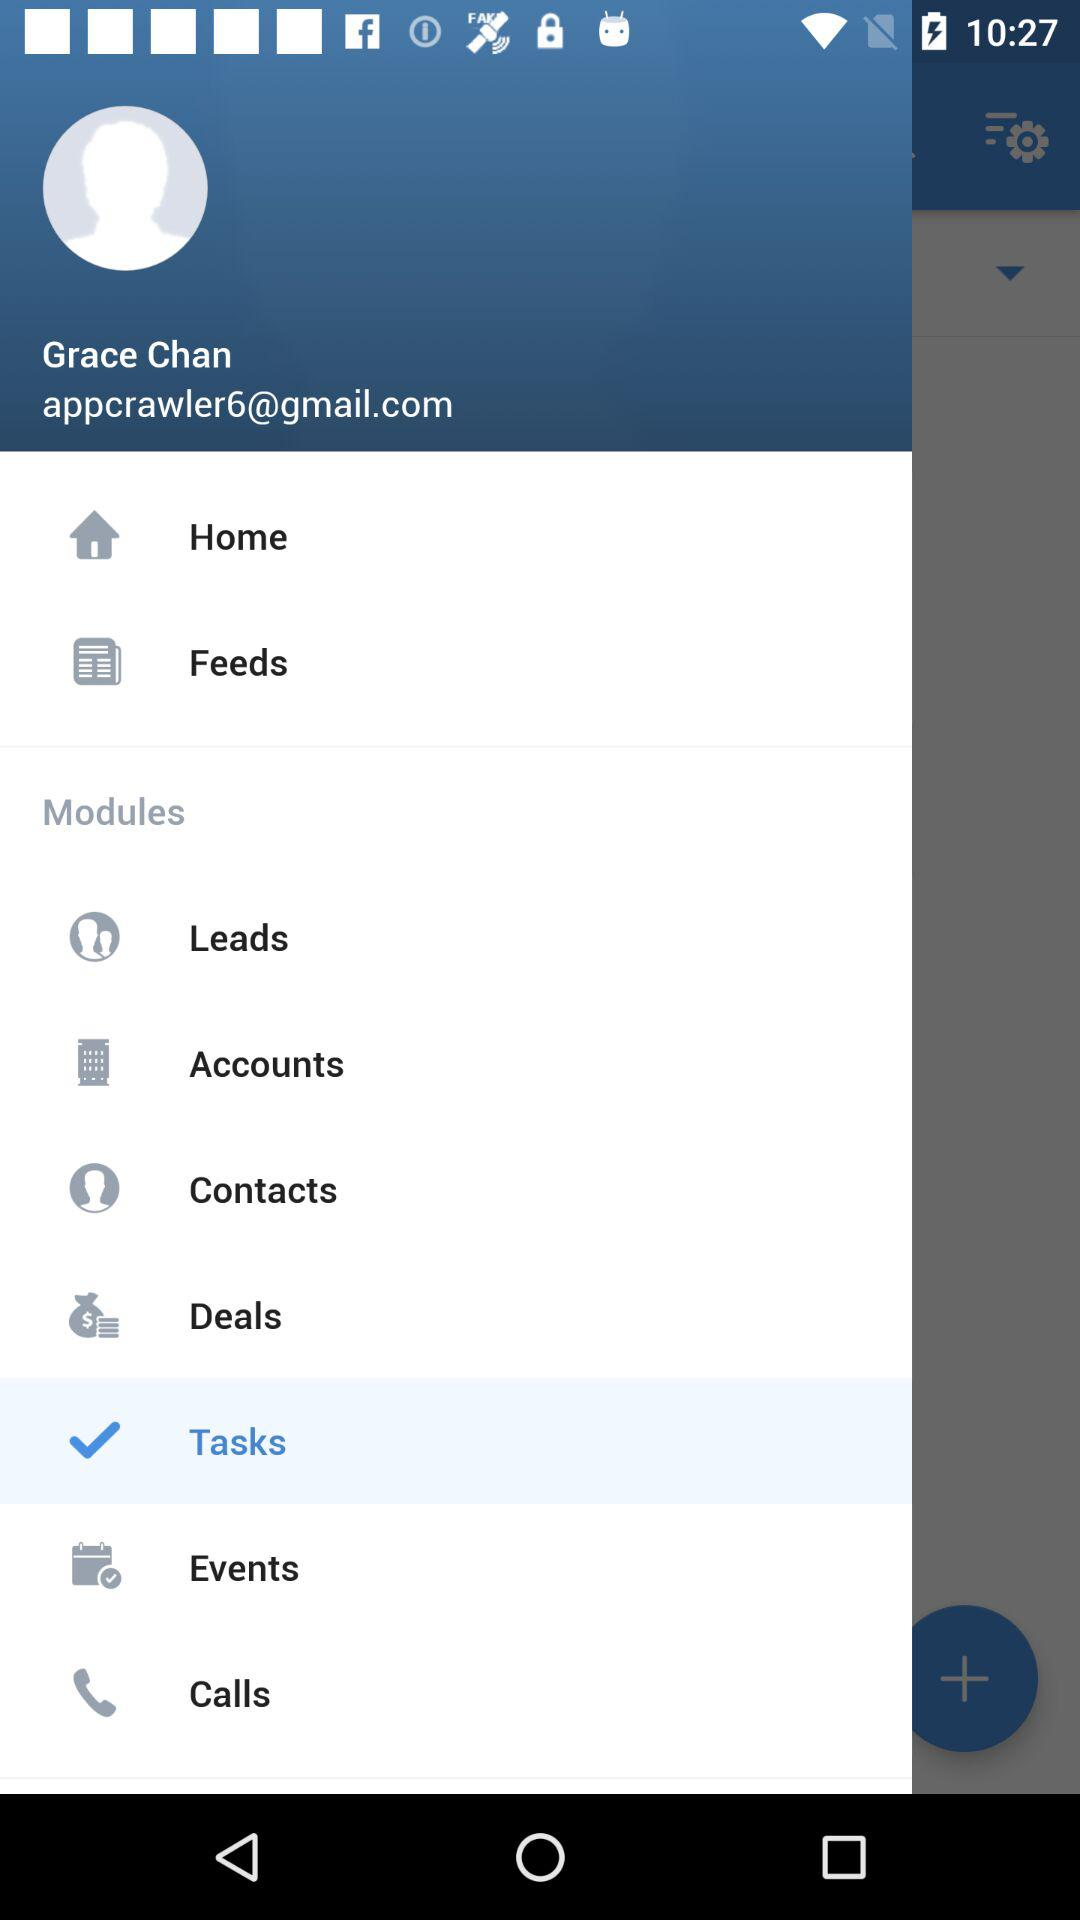What Gmail address is used? The used Gmail address is appcrawler6@gmail.com. 